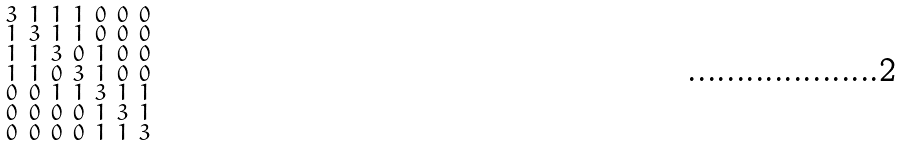<formula> <loc_0><loc_0><loc_500><loc_500>\begin{smallmatrix} 3 & 1 & 1 & 1 & 0 & 0 & 0 \\ 1 & 3 & 1 & 1 & 0 & 0 & 0 \\ 1 & 1 & 3 & 0 & 1 & 0 & 0 \\ 1 & 1 & 0 & 3 & 1 & 0 & 0 \\ 0 & 0 & 1 & 1 & 3 & 1 & 1 \\ 0 & 0 & 0 & 0 & 1 & 3 & 1 \\ 0 & 0 & 0 & 0 & 1 & 1 & 3 \end{smallmatrix}</formula> 